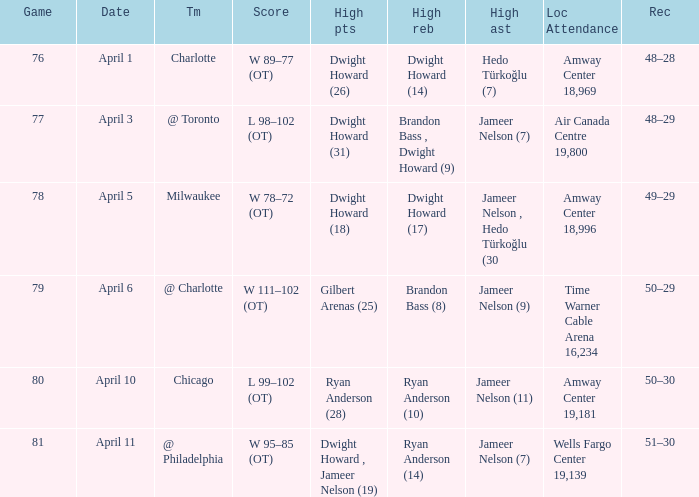At which place was the game held, and what was the crowd size on april 3? Air Canada Centre 19,800. 